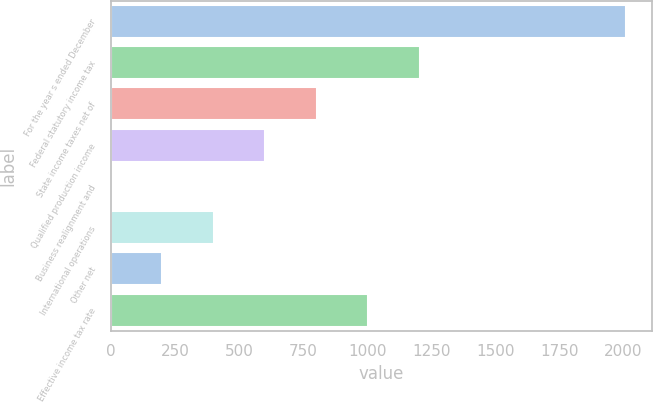Convert chart. <chart><loc_0><loc_0><loc_500><loc_500><bar_chart><fcel>For the year s ended December<fcel>Federal statutory income tax<fcel>State income taxes net of<fcel>Qualified production income<fcel>Business realignment and<fcel>International operations<fcel>Other net<fcel>Effective income tax rate<nl><fcel>2011<fcel>1206.64<fcel>804.46<fcel>603.37<fcel>0.1<fcel>402.28<fcel>201.19<fcel>1005.55<nl></chart> 